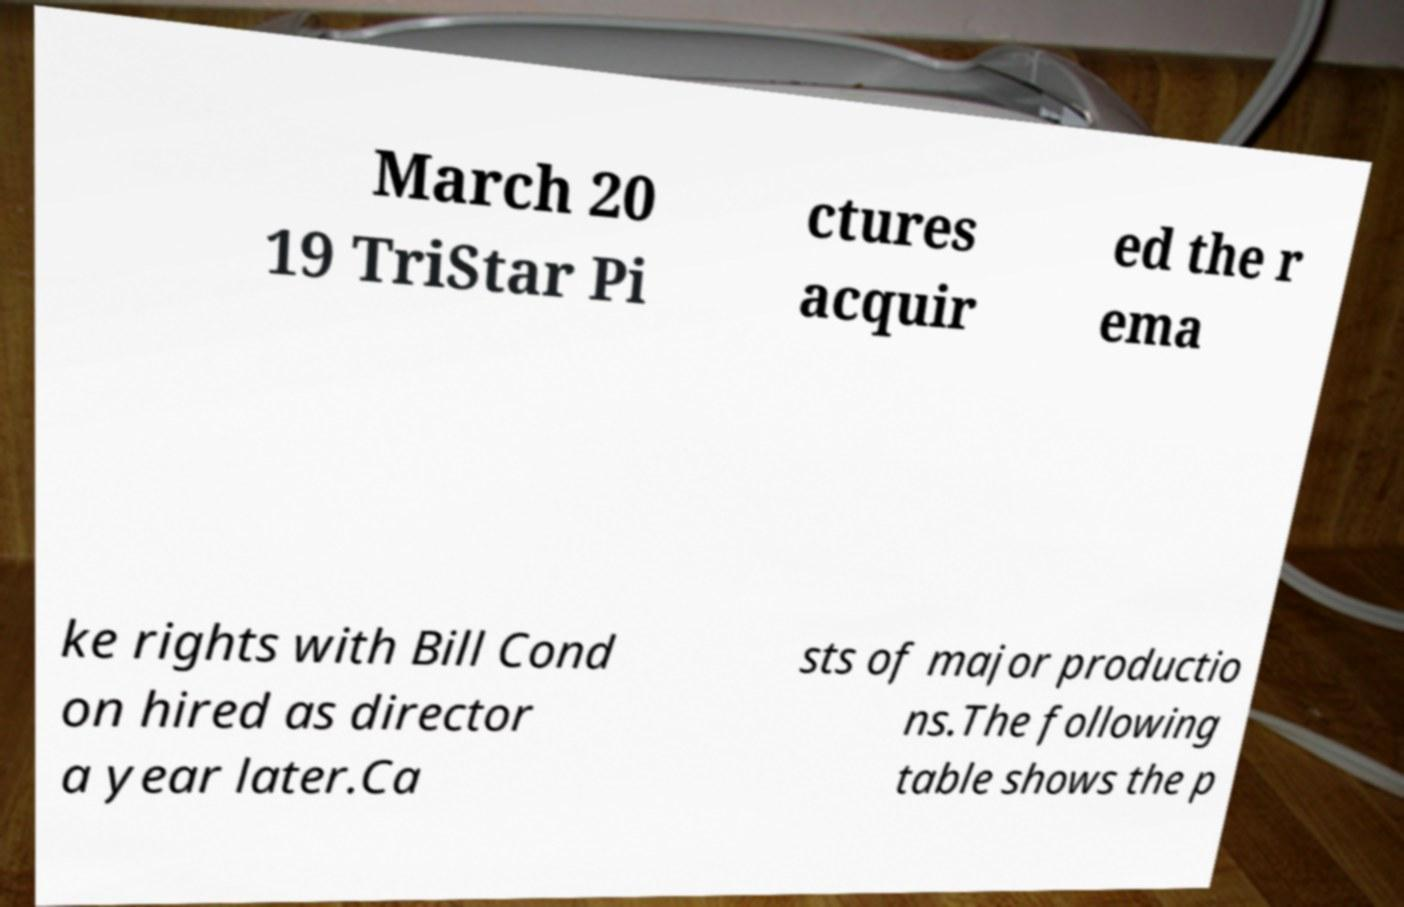What messages or text are displayed in this image? I need them in a readable, typed format. March 20 19 TriStar Pi ctures acquir ed the r ema ke rights with Bill Cond on hired as director a year later.Ca sts of major productio ns.The following table shows the p 